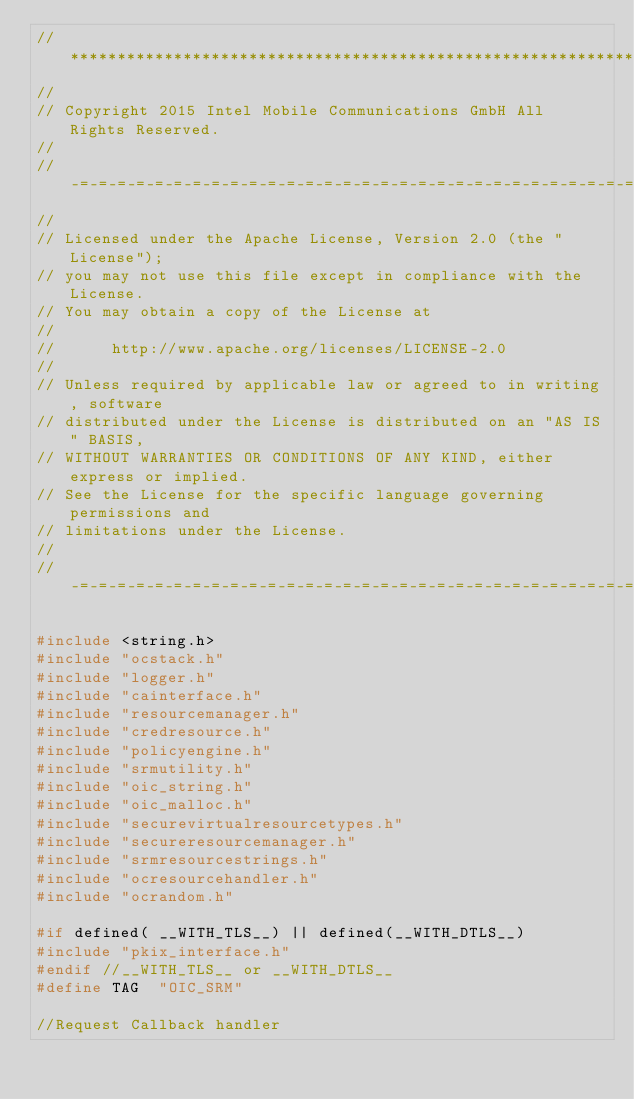<code> <loc_0><loc_0><loc_500><loc_500><_C_>//******************************************************************
//
// Copyright 2015 Intel Mobile Communications GmbH All Rights Reserved.
//
//-=-=-=-=-=-=-=-=-=-=-=-=-=-=-=-=-=-=-=-=-=-=-=-=-=-=-=-=-=-=-=-=
//
// Licensed under the Apache License, Version 2.0 (the "License");
// you may not use this file except in compliance with the License.
// You may obtain a copy of the License at
//
//      http://www.apache.org/licenses/LICENSE-2.0
//
// Unless required by applicable law or agreed to in writing, software
// distributed under the License is distributed on an "AS IS" BASIS,
// WITHOUT WARRANTIES OR CONDITIONS OF ANY KIND, either express or implied.
// See the License for the specific language governing permissions and
// limitations under the License.
//
//-=-=-=-=-=-=-=-=-=-=-=-=-=-=-=-=-=-=-=-=-=-=-=-=-=-=-=-=-=-=-=-=

#include <string.h>
#include "ocstack.h"
#include "logger.h"
#include "cainterface.h"
#include "resourcemanager.h"
#include "credresource.h"
#include "policyengine.h"
#include "srmutility.h"
#include "oic_string.h"
#include "oic_malloc.h"
#include "securevirtualresourcetypes.h"
#include "secureresourcemanager.h"
#include "srmresourcestrings.h"
#include "ocresourcehandler.h"
#include "ocrandom.h"

#if defined( __WITH_TLS__) || defined(__WITH_DTLS__)
#include "pkix_interface.h"
#endif //__WITH_TLS__ or __WITH_DTLS__
#define TAG  "OIC_SRM"

//Request Callback handler</code> 